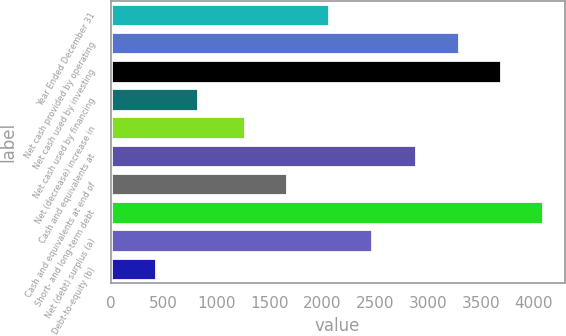Convert chart. <chart><loc_0><loc_0><loc_500><loc_500><bar_chart><fcel>Year Ended December 31<fcel>Net cash provided by operating<fcel>Net cash used by investing<fcel>Net cash used by financing<fcel>Net (decrease) increase in<fcel>Cash and equivalents at<fcel>Cash and equivalents at end of<fcel>Short- and long-term debt<fcel>Net (debt) surplus (a)<fcel>Debt-to-equity (b)<nl><fcel>2069.08<fcel>3290.54<fcel>3690.08<fcel>827.68<fcel>1270<fcel>2891<fcel>1669.54<fcel>4089.62<fcel>2468.62<fcel>428.14<nl></chart> 